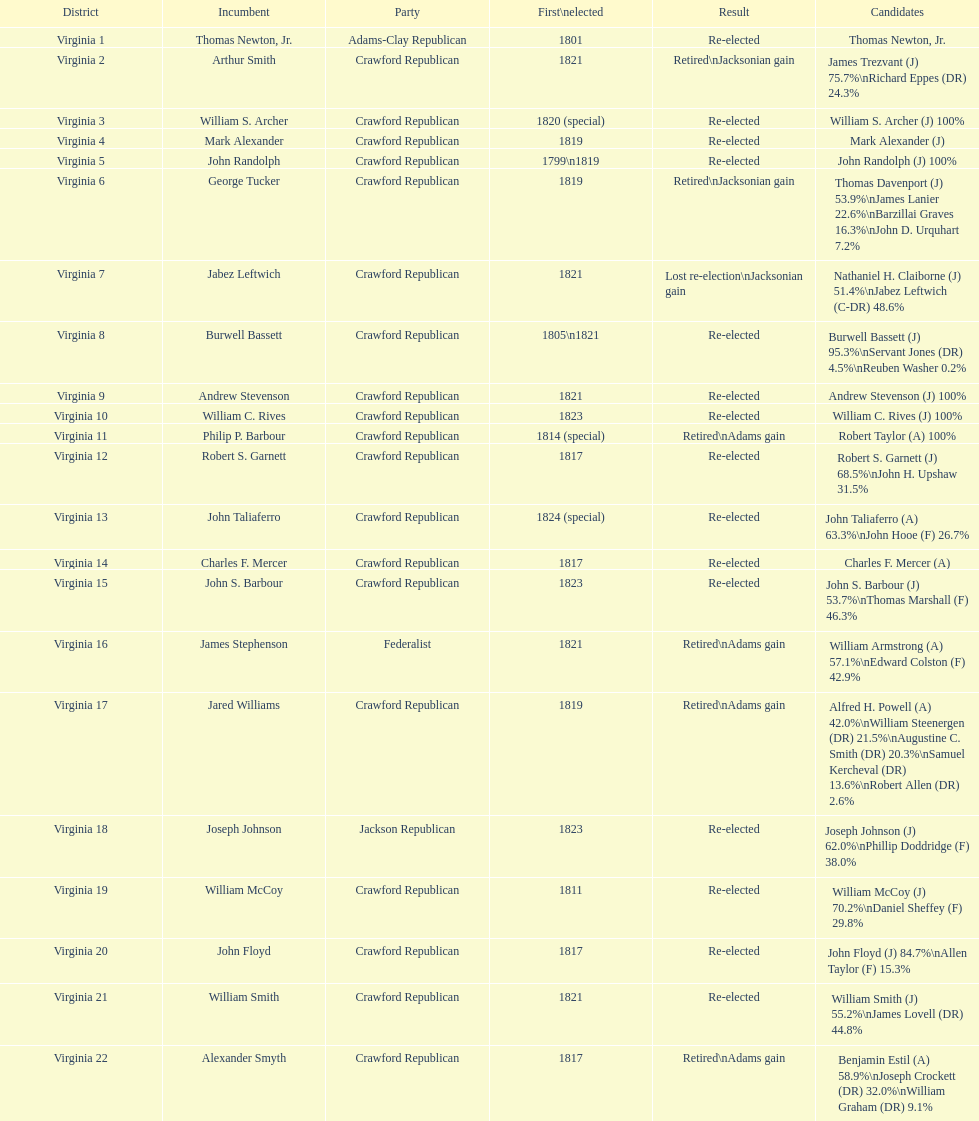Number of incumbents who retired or lost re-election 7. 